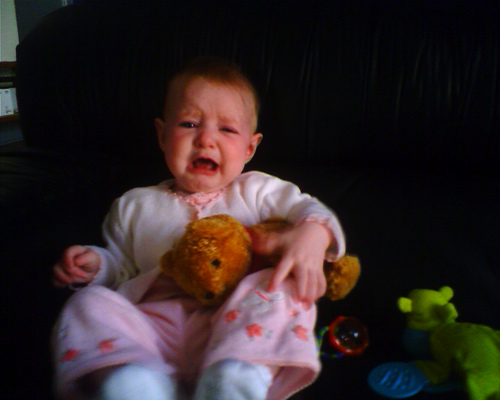<image>What cartoon characters are on the high chair cover? It is unknown what cartoon characters are on the high chair cover. It can be none or dora. What is the little girl sitting in? I am not sure what the little girl is sitting in. It could be a chair or a couch. What cartoon characters are on the high chair cover? There are no cartoon characters on the high chair cover. What is the little girl sitting in? I don't know what the little girl is sitting in. It can be either a carpet, couch, or chair. 